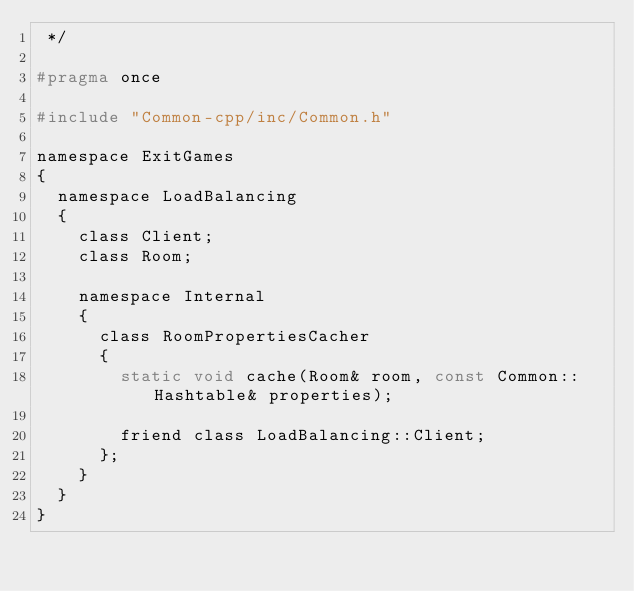Convert code to text. <code><loc_0><loc_0><loc_500><loc_500><_C_> */

#pragma once

#include "Common-cpp/inc/Common.h"

namespace ExitGames
{
	namespace LoadBalancing
	{
		class Client;
		class Room;

		namespace Internal
		{
			class RoomPropertiesCacher
			{
				static void cache(Room& room, const Common::Hashtable& properties);

				friend class LoadBalancing::Client;
			};
		}
	}
}</code> 